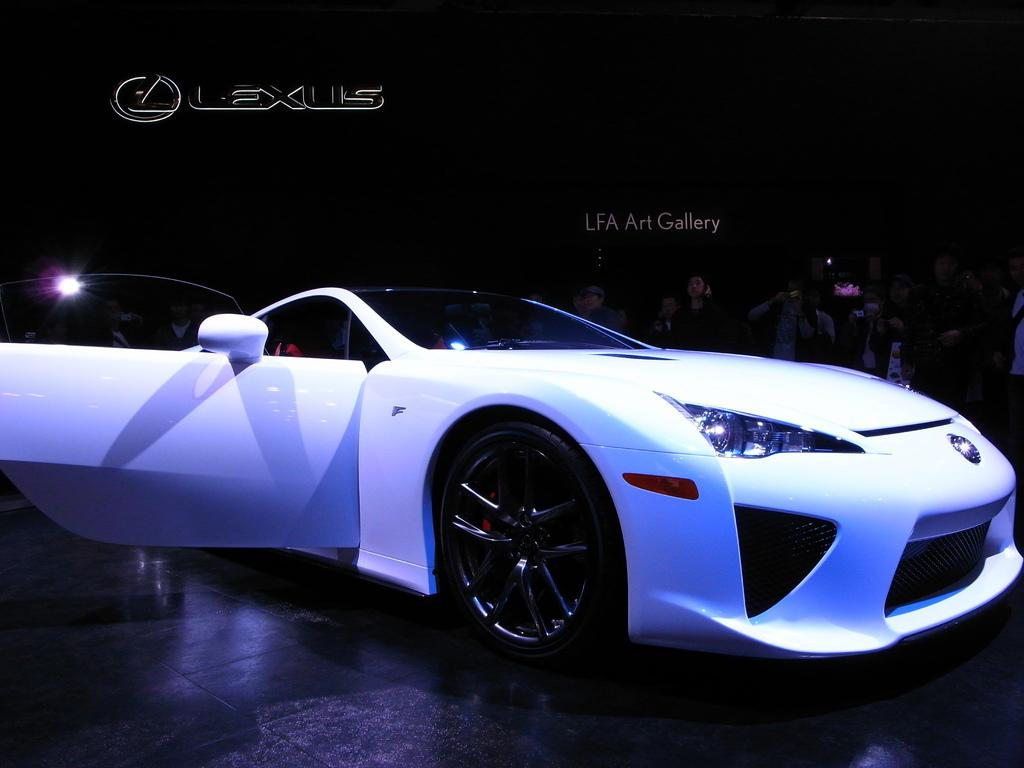What is the main subject in the foreground of the image? There is a car in the foreground of the image. What is the color of the surface the car is on? The car is on a black surface. What can be seen in the background of the image? There are persons standing in the background of the image. How would you describe the lighting in the image? The background appears to be dark. How many centimeters does the lift move up and down in the image? There is no lift present in the image, so it is not possible to determine how many centimeters it moves up and down. 